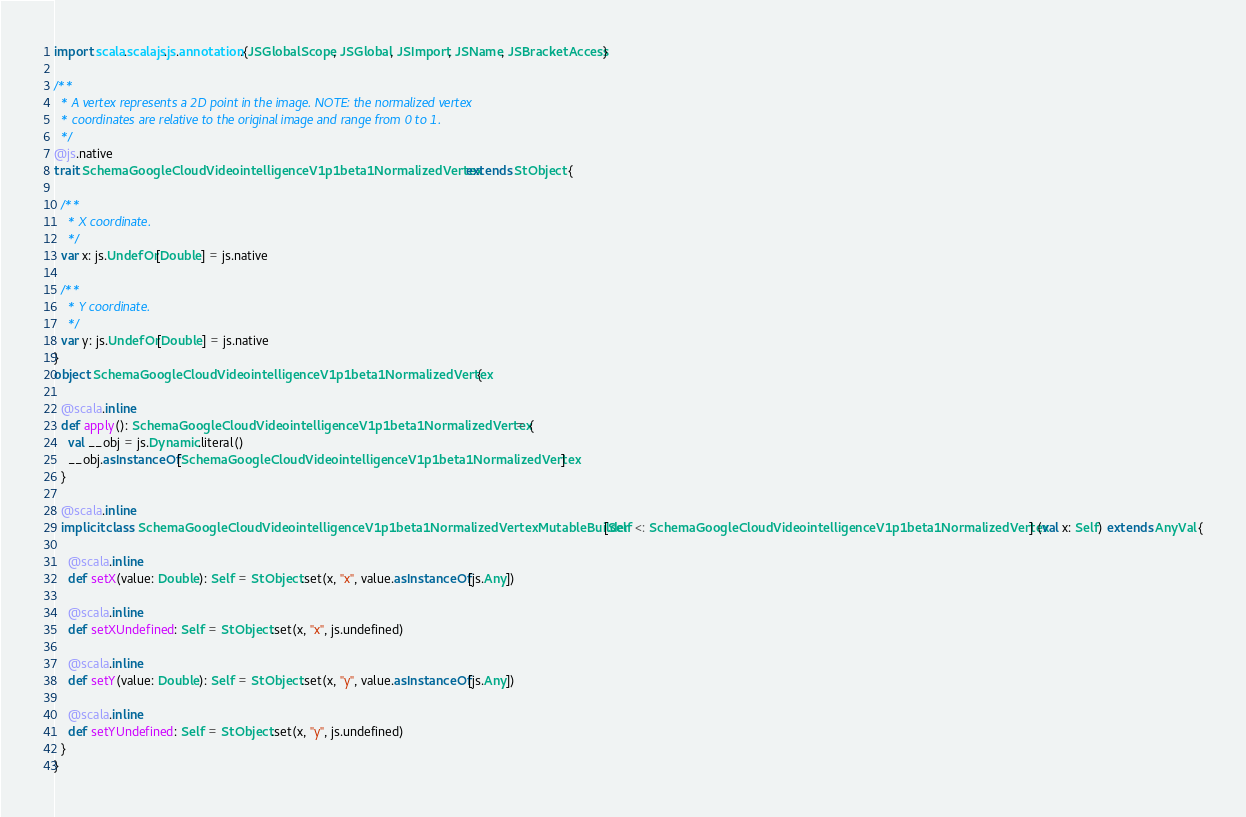<code> <loc_0><loc_0><loc_500><loc_500><_Scala_>import scala.scalajs.js.annotation.{JSGlobalScope, JSGlobal, JSImport, JSName, JSBracketAccess}

/**
  * A vertex represents a 2D point in the image. NOTE: the normalized vertex
  * coordinates are relative to the original image and range from 0 to 1.
  */
@js.native
trait SchemaGoogleCloudVideointelligenceV1p1beta1NormalizedVertex extends StObject {
  
  /**
    * X coordinate.
    */
  var x: js.UndefOr[Double] = js.native
  
  /**
    * Y coordinate.
    */
  var y: js.UndefOr[Double] = js.native
}
object SchemaGoogleCloudVideointelligenceV1p1beta1NormalizedVertex {
  
  @scala.inline
  def apply(): SchemaGoogleCloudVideointelligenceV1p1beta1NormalizedVertex = {
    val __obj = js.Dynamic.literal()
    __obj.asInstanceOf[SchemaGoogleCloudVideointelligenceV1p1beta1NormalizedVertex]
  }
  
  @scala.inline
  implicit class SchemaGoogleCloudVideointelligenceV1p1beta1NormalizedVertexMutableBuilder[Self <: SchemaGoogleCloudVideointelligenceV1p1beta1NormalizedVertex] (val x: Self) extends AnyVal {
    
    @scala.inline
    def setX(value: Double): Self = StObject.set(x, "x", value.asInstanceOf[js.Any])
    
    @scala.inline
    def setXUndefined: Self = StObject.set(x, "x", js.undefined)
    
    @scala.inline
    def setY(value: Double): Self = StObject.set(x, "y", value.asInstanceOf[js.Any])
    
    @scala.inline
    def setYUndefined: Self = StObject.set(x, "y", js.undefined)
  }
}
</code> 